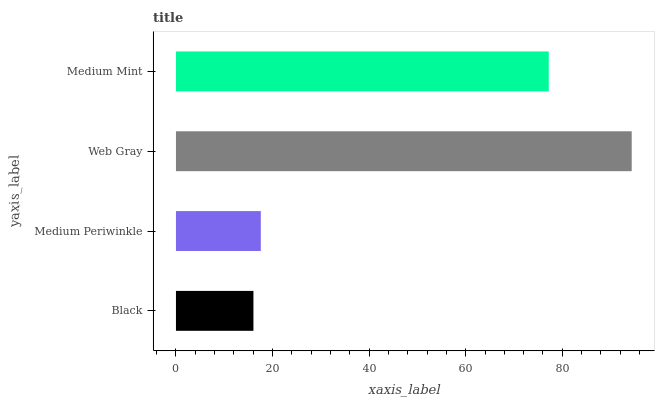Is Black the minimum?
Answer yes or no. Yes. Is Web Gray the maximum?
Answer yes or no. Yes. Is Medium Periwinkle the minimum?
Answer yes or no. No. Is Medium Periwinkle the maximum?
Answer yes or no. No. Is Medium Periwinkle greater than Black?
Answer yes or no. Yes. Is Black less than Medium Periwinkle?
Answer yes or no. Yes. Is Black greater than Medium Periwinkle?
Answer yes or no. No. Is Medium Periwinkle less than Black?
Answer yes or no. No. Is Medium Mint the high median?
Answer yes or no. Yes. Is Medium Periwinkle the low median?
Answer yes or no. Yes. Is Black the high median?
Answer yes or no. No. Is Medium Mint the low median?
Answer yes or no. No. 